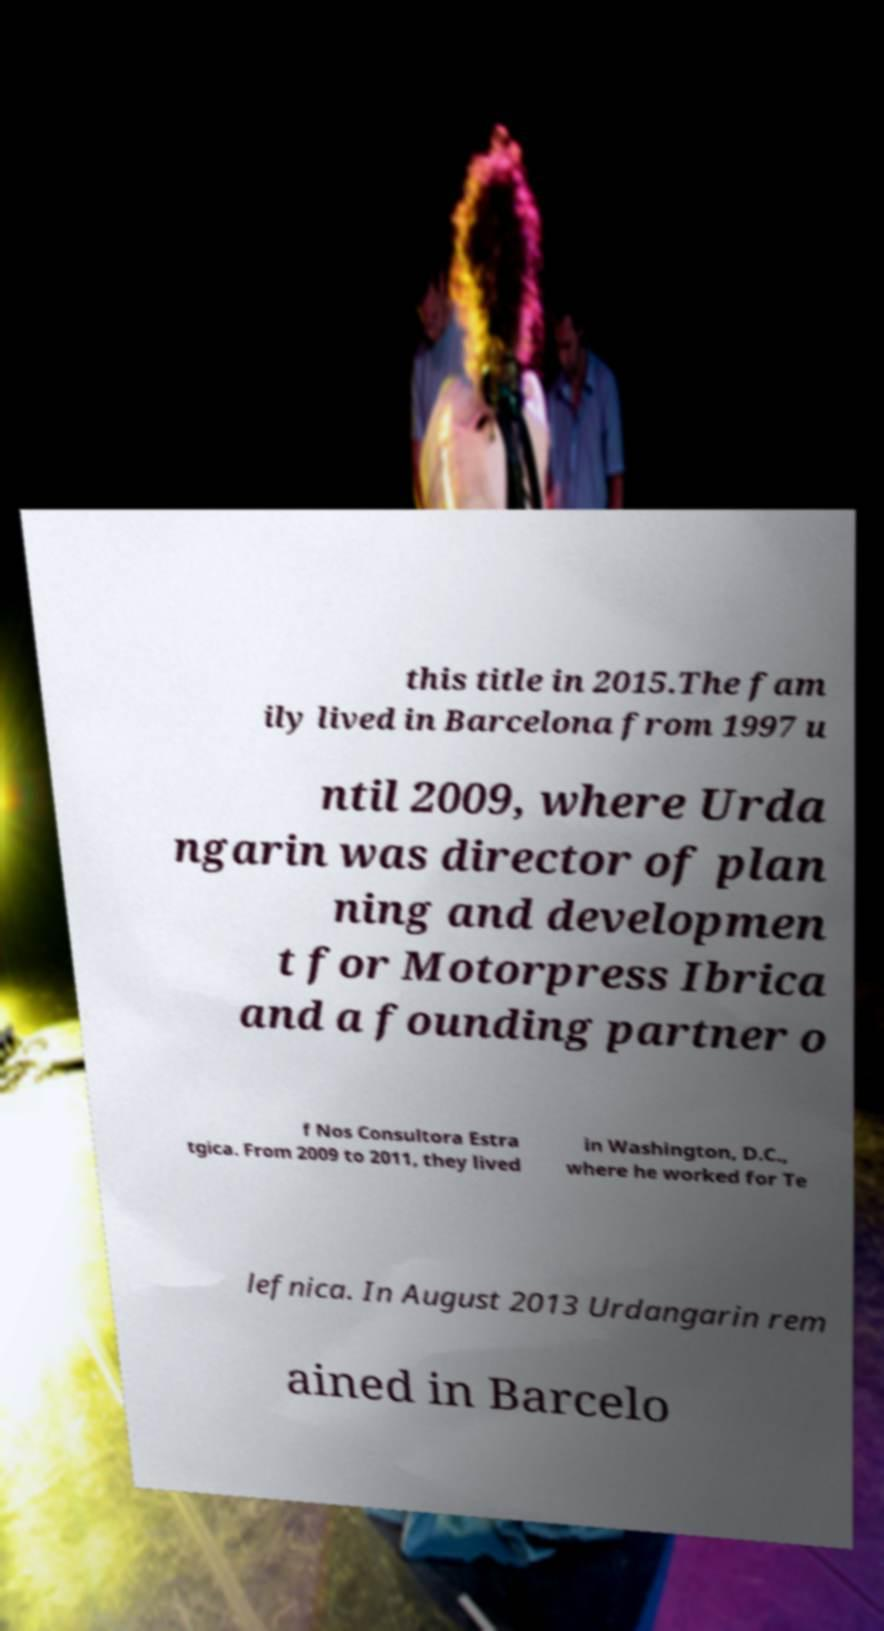Please read and relay the text visible in this image. What does it say? this title in 2015.The fam ily lived in Barcelona from 1997 u ntil 2009, where Urda ngarin was director of plan ning and developmen t for Motorpress Ibrica and a founding partner o f Nos Consultora Estra tgica. From 2009 to 2011, they lived in Washington, D.C., where he worked for Te lefnica. In August 2013 Urdangarin rem ained in Barcelo 